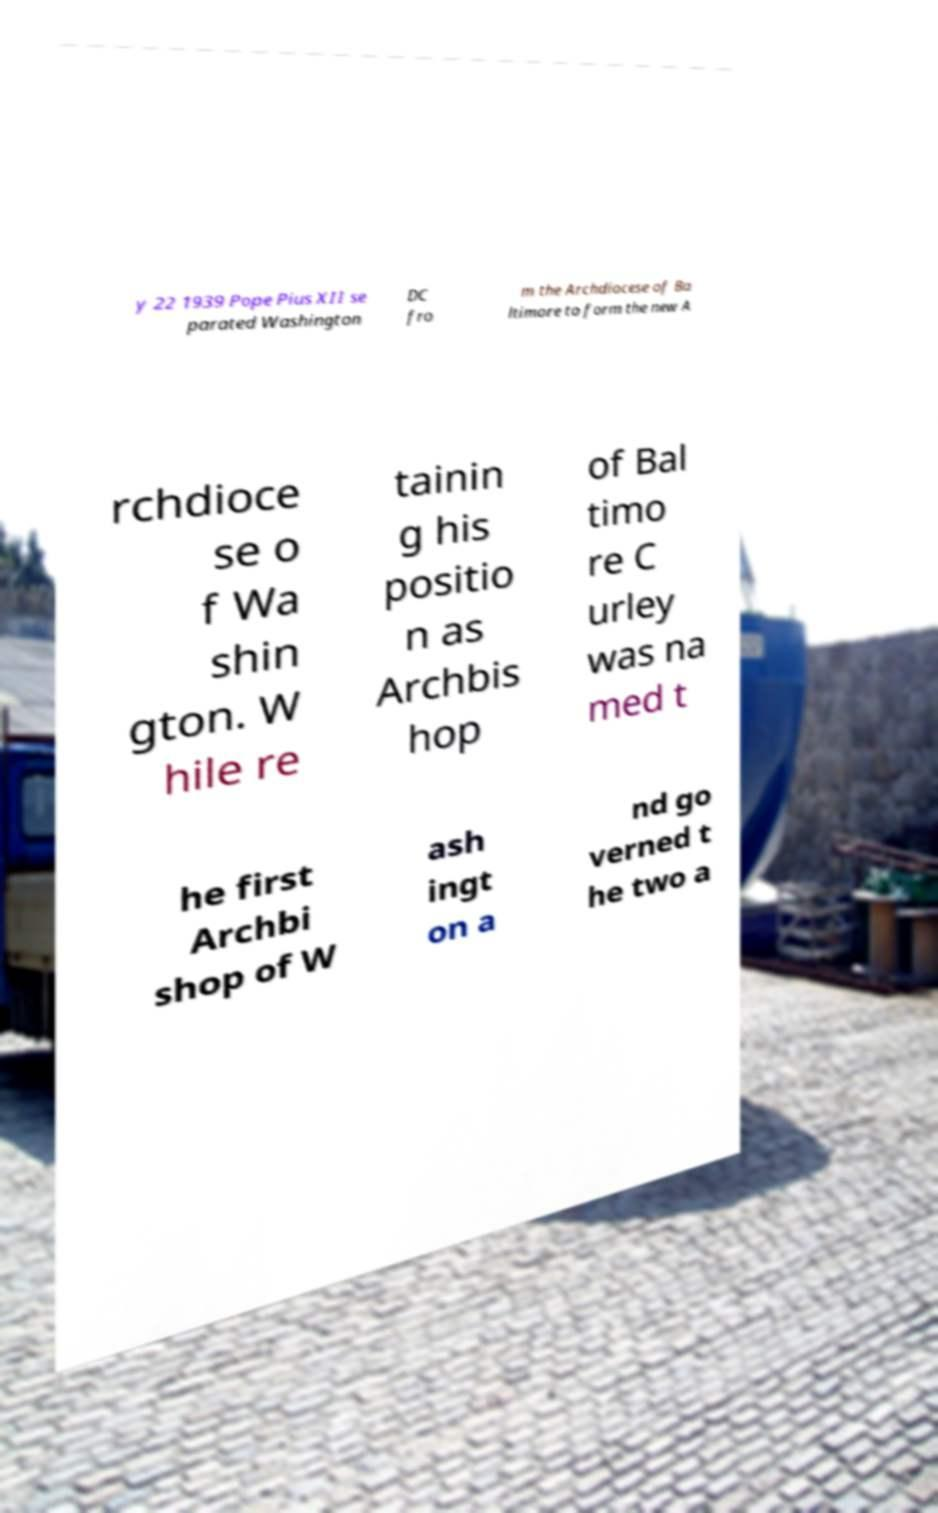Can you accurately transcribe the text from the provided image for me? y 22 1939 Pope Pius XII se parated Washington DC fro m the Archdiocese of Ba ltimore to form the new A rchdioce se o f Wa shin gton. W hile re tainin g his positio n as Archbis hop of Bal timo re C urley was na med t he first Archbi shop of W ash ingt on a nd go verned t he two a 